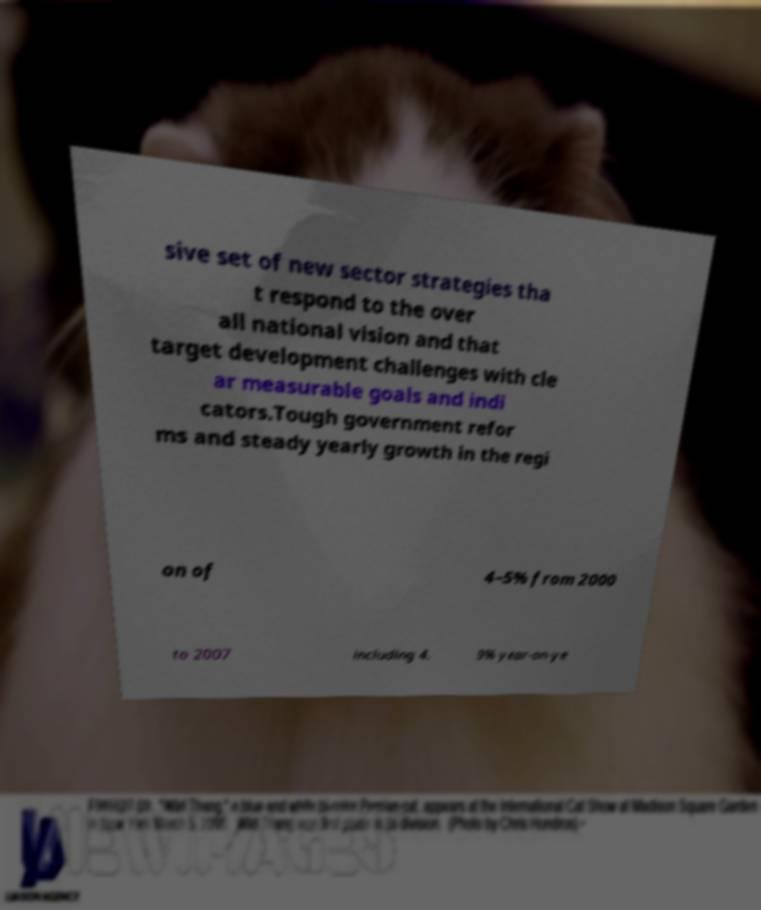Can you accurately transcribe the text from the provided image for me? sive set of new sector strategies tha t respond to the over all national vision and that target development challenges with cle ar measurable goals and indi cators.Tough government refor ms and steady yearly growth in the regi on of 4–5% from 2000 to 2007 including 4. 9% year-on-ye 